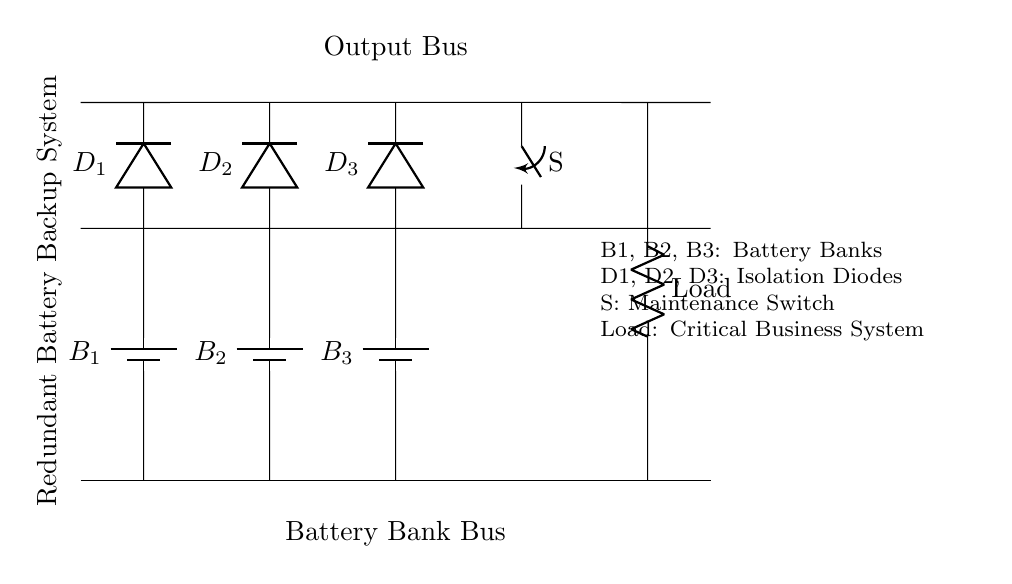What type of circuit is this? This circuit is a parallel circuit as indicated by the configuration of multiple battery banks connected alongside each other to a common output bus, allowing current to flow through multiple paths.
Answer: Parallel circuit How many battery banks are in the circuit? The circuit diagram shows three battery banks labeled B1, B2, and B3, which are represented by the three battery icons connected in parallel to the output.
Answer: Three What is the purpose of the diodes in this circuit? The diodes (D1, D2, D3) are used to prevent reverse current flow from the output back into the battery banks; they ensure that only the battery with the highest voltage is supplying power to the load at any time.
Answer: Prevent reverse current What happens if one battery bank fails? If one battery bank fails, the remaining battery banks (B2 and B3) continue to supply power to the load without interruption, enhancing system reliability.
Answer: Other banks continue What is the significance of the switch in the circuit? The switch (S) allows for maintenance on the circuit, enabling the isolation of the circuits for repair or battery replacement without affecting the operation of the load connected to the output.
Answer: Maintenance What is the load in this system? The load is indicated by a resistor labeled 'Load', representing the critical business system that requires continuous power from the battery banks.
Answer: Critical business system What does having multiple diodes indicate about the system? The presence of multiple diodes implies that the system is designed to ensure that individual battery contributions can be controlled, thus preventing any single point of failure, which adds redundancy to the power supply.
Answer: Redundancy in power supply 